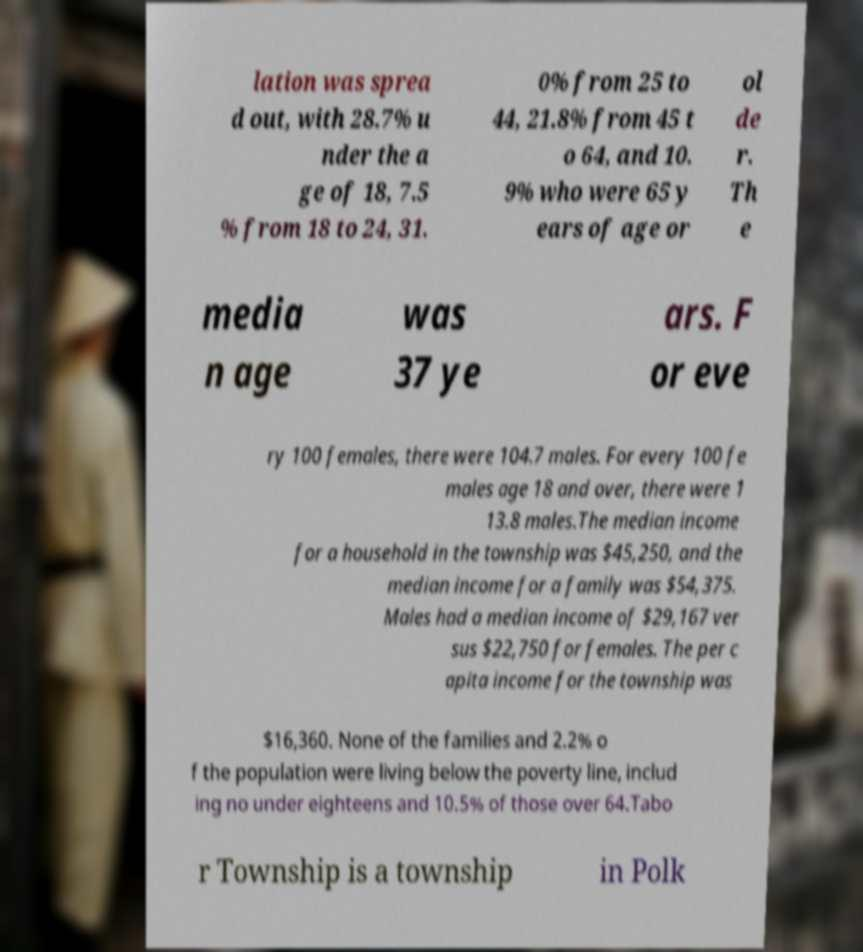For documentation purposes, I need the text within this image transcribed. Could you provide that? lation was sprea d out, with 28.7% u nder the a ge of 18, 7.5 % from 18 to 24, 31. 0% from 25 to 44, 21.8% from 45 t o 64, and 10. 9% who were 65 y ears of age or ol de r. Th e media n age was 37 ye ars. F or eve ry 100 females, there were 104.7 males. For every 100 fe males age 18 and over, there were 1 13.8 males.The median income for a household in the township was $45,250, and the median income for a family was $54,375. Males had a median income of $29,167 ver sus $22,750 for females. The per c apita income for the township was $16,360. None of the families and 2.2% o f the population were living below the poverty line, includ ing no under eighteens and 10.5% of those over 64.Tabo r Township is a township in Polk 